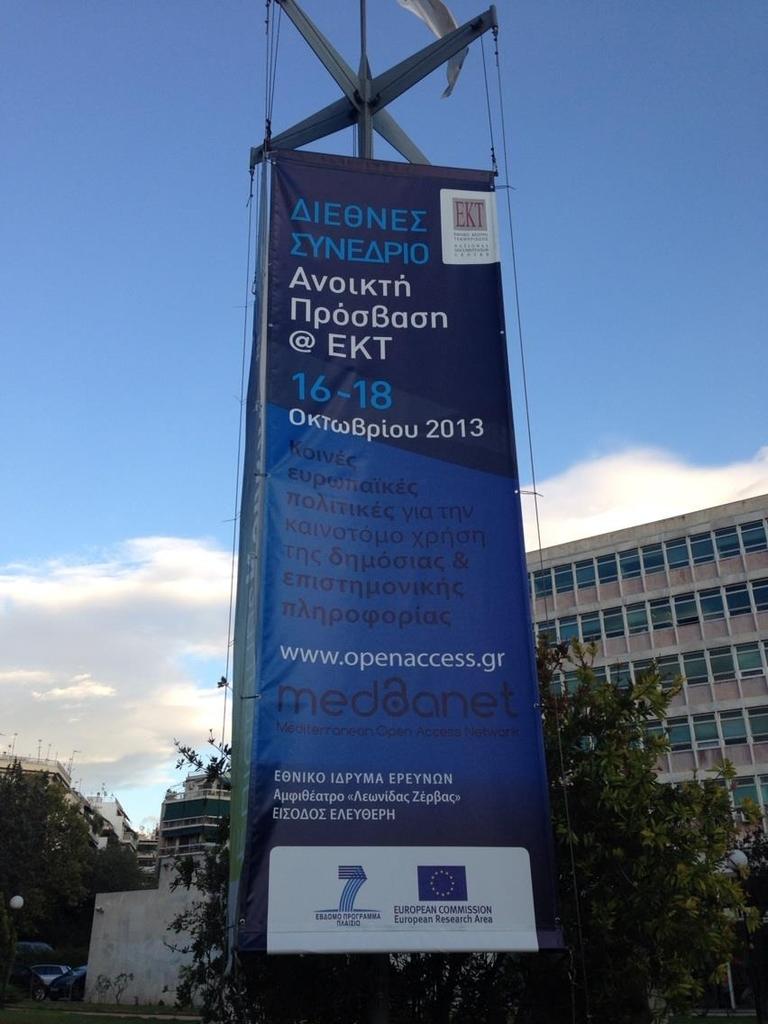What is the domain name?
Provide a short and direct response. Openaccess.gr. What year does the sign say?
Ensure brevity in your answer.  2013. 